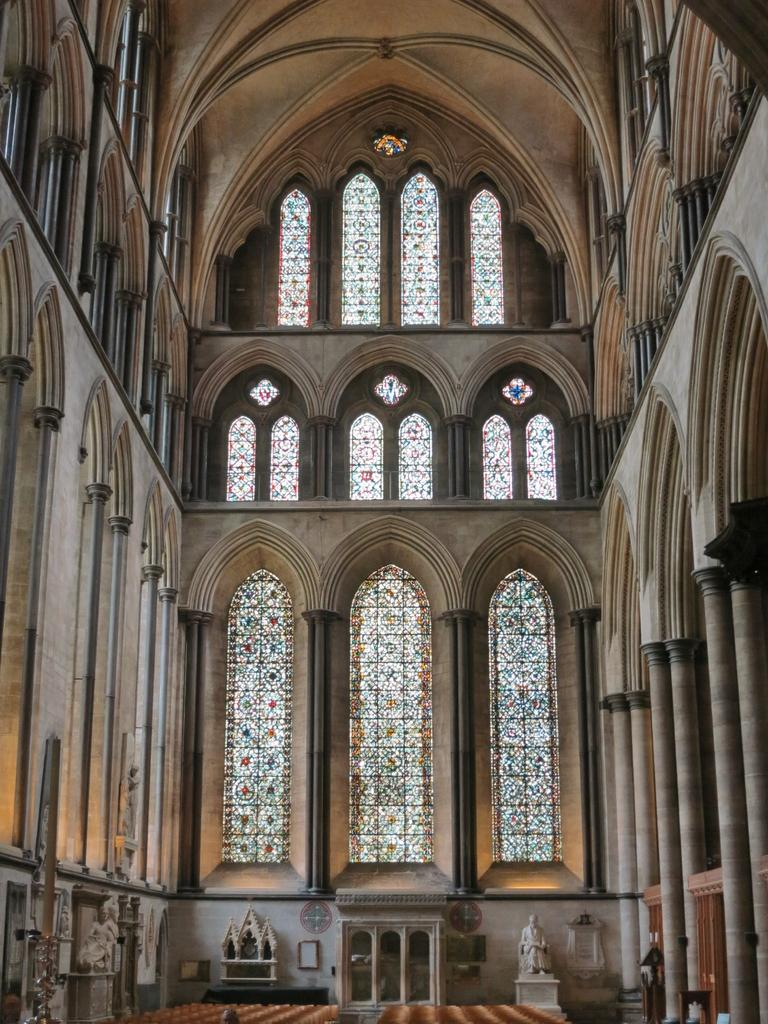What type of structure can be seen in the image? There is a wall in the image. Are there any openings in the wall? Yes, there are windows in the image. What other object is present in the image? There is a statue in the image. What might be used for standing or sitting on in the image? There is a mat in the image. What type of ship can be seen in the image? There is no ship present in the image. Can you describe the coat that the statue is wearing in the image? There is no coat mentioned in the image, and the statue does not appear to be wearing any clothing. 